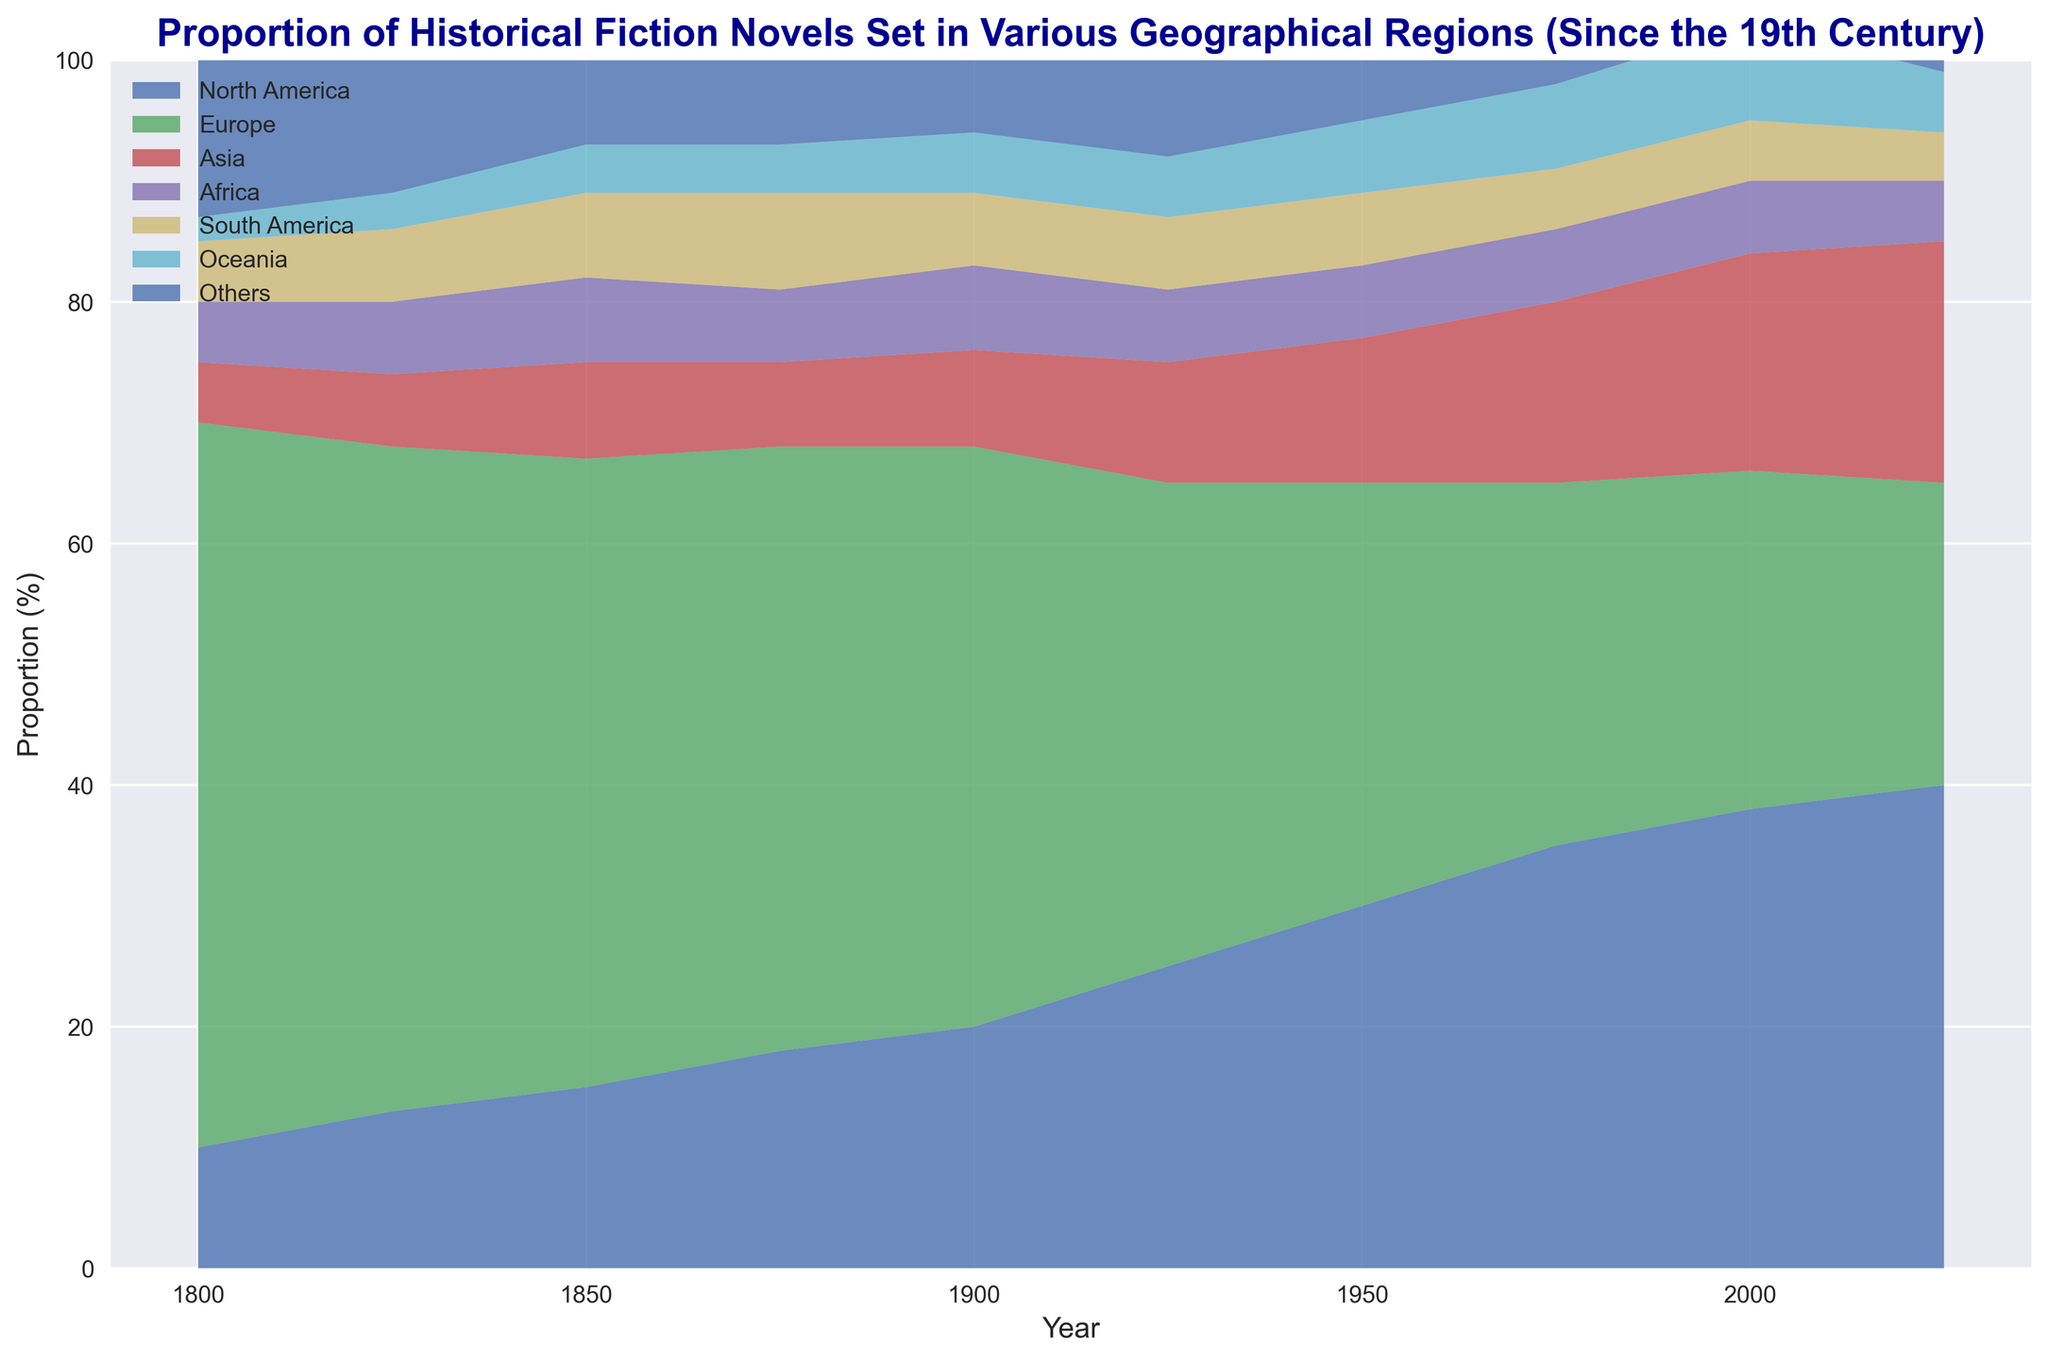What's the overall trend for Europe over time? Looking at the area representing Europe from 1800 to 2025, we see a clear gradual decline. Europe starts at around 60% in 1800 but decreases to 25% by 2025.
Answer: Gradual decline Which region showed a steady increase in its proportion from 1800 to 1975? Observing the areas, North America shows a steady increase, starting at 10% in 1800 and reaching 35% by 1975.
Answer: North America Between 1950 and 2000, which region had the highest proportional increase? Comparing the proportions from 1950 to 2000, Asia increases from 12% to 18%, a 6% rise, which is higher compared to changes in other regions during the same period.
Answer: Asia How does the proportion of novels set in Oceania in 2000 compare to 1800? In 1800, the proportion for Oceania is 2%, and by 2000 it increases to 8%. This shows a notable increase in representation for Oceania.
Answer: Increased From 1800 to 2025, which two regions maintained the most stable proportions? Examining the trend lines, Africa and South America show relatively stable proportions with minor fluctuations around 5-8% throughout the period.
Answer: Africa and South America In which year did Europe and North America show the same proportion? Observing the chart, around 2025 both Europe and North America have similar proportions, with Europe at 25% and North America at 40%, which are close in proportional change trends but not exactly the same; thus, possibly indicating a crossover earlier not in the given years directly.
Answer: No exact match Which region showed a proportional decline in recent decades (2000 to 2025)? Comparing values in 2000 and 2025, Europe declines from 28% to 25%, indicating a recent decrease.
Answer: Europe If you combine the proportions of Asia and Oceania in 1975, what is the total? In 1975, Asia is 15% and Oceania is 7%. Combining these, 15% + 7% results in 22%.
Answer: 22% By how much did North America’s proportion increase from 1800 to 2025? North America’s proportion increases from 10% in 1800 to 40% in 2025. The increase is 40% - 10% = 30%.
Answer: 30% In 2000, which region had the lowest proportion of historical fiction novels? Observing the proportions for 2000, 'Others' had the lowest with 2%.
Answer: Others 